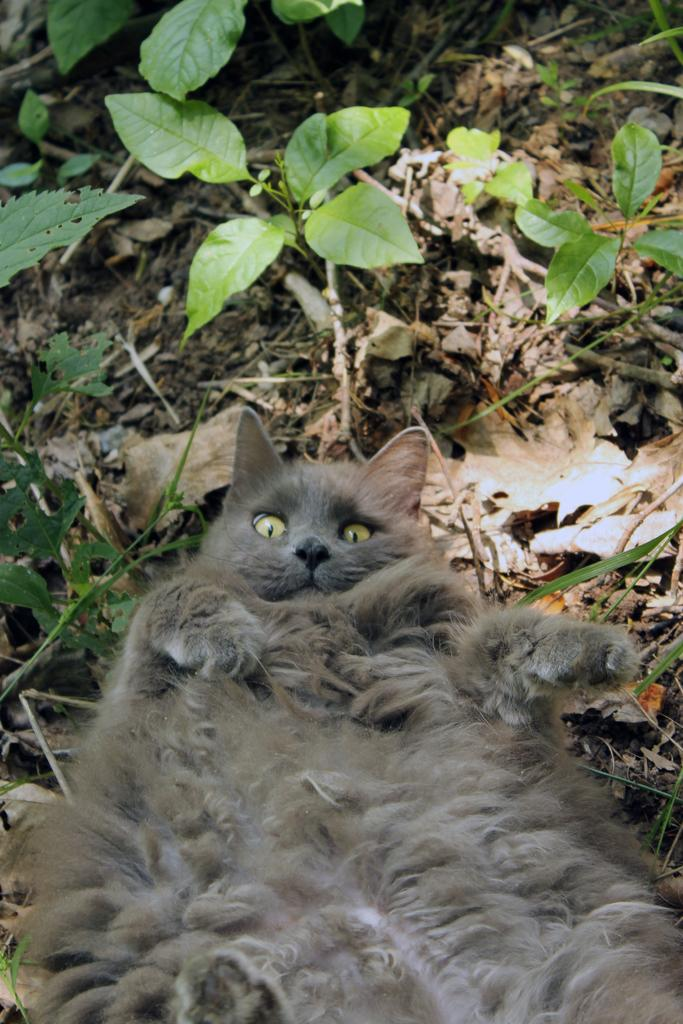What type of animal is in the image? There is a cat in the image. What natural elements can be seen in the image? There are dried leaves and plants in the image. What is the cat's opinion on the current political climate in the image? The image does not provide any information about the cat's opinion on the current political climate, as it is not relevant to the image's content. 